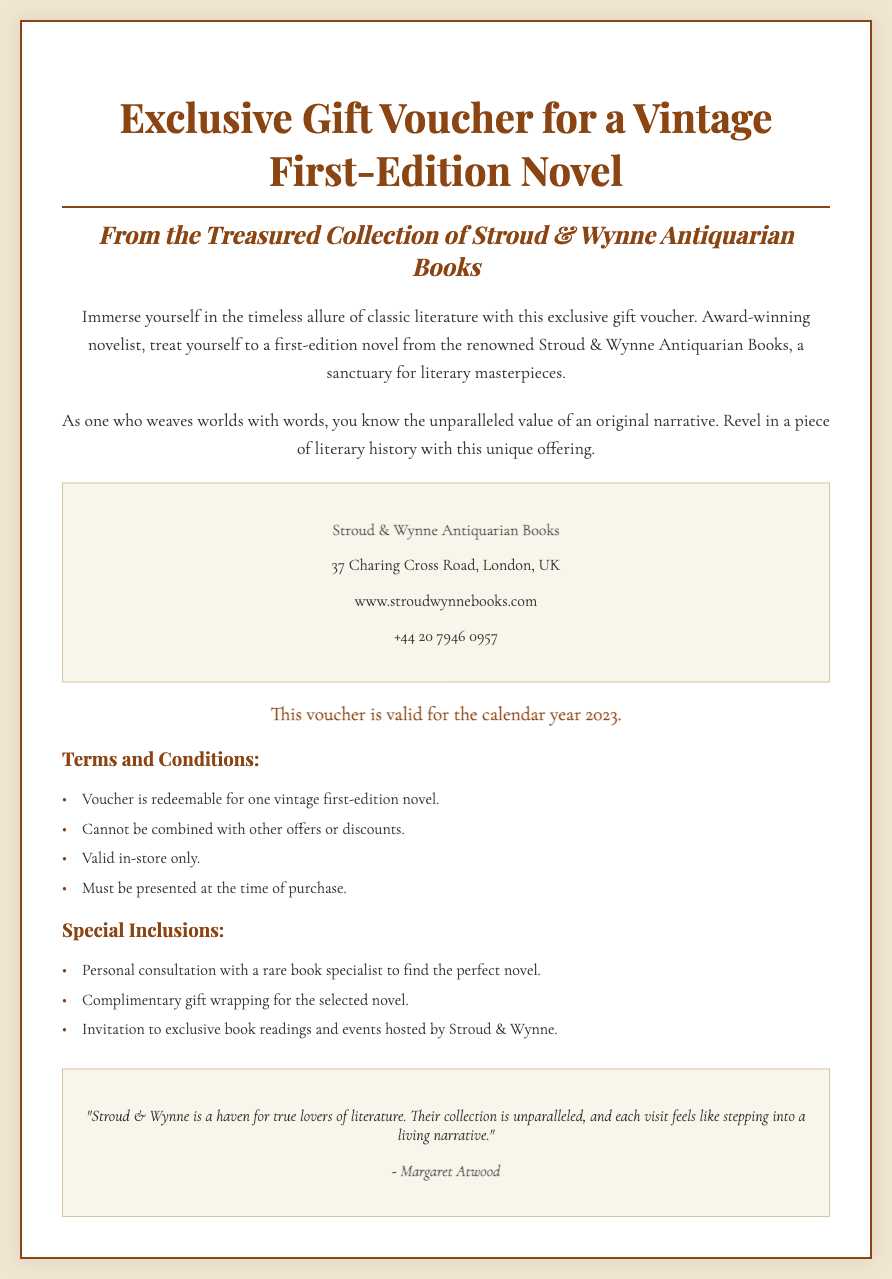What is the title of the voucher? The title of the voucher is prominently displayed at the top of the document.
Answer: Exclusive Gift Voucher for a Vintage First-Edition Novel Who is the renowned bookstore mentioned in the voucher? The voucher identifies the bookstore as a key part of its offering.
Answer: Stroud & Wynne Antiquarian Books What is the address of Stroud & Wynne Antiquarian Books? The address is provided in the details section of the voucher.
Answer: 37 Charing Cross Road, London, UK What year is the voucher valid for? The validity section states the specific timeframe for use.
Answer: 2023 What special inclusion offers a chance to interact with a book specialist? This inclusion is noted in the list of special offerings related to the voucher.
Answer: Personal consultation with a rare book specialist How many special inclusions are listed in the document? The number of inclusions can be counted from the respective section.
Answer: Three Is this voucher valid for online purchases? The nature of the voucher's validity is clarified within the terms and conditions.
Answer: No Who endorsed Stroud & Wynne Antiquarian Books? An endorsement section features the name of a prominent figure related to literature.
Answer: Margaret Atwood What is offered as part of the complimentary service mentioned? The document specifies one of the complimentary services included with the voucher.
Answer: Gift wrapping for the selected novel 